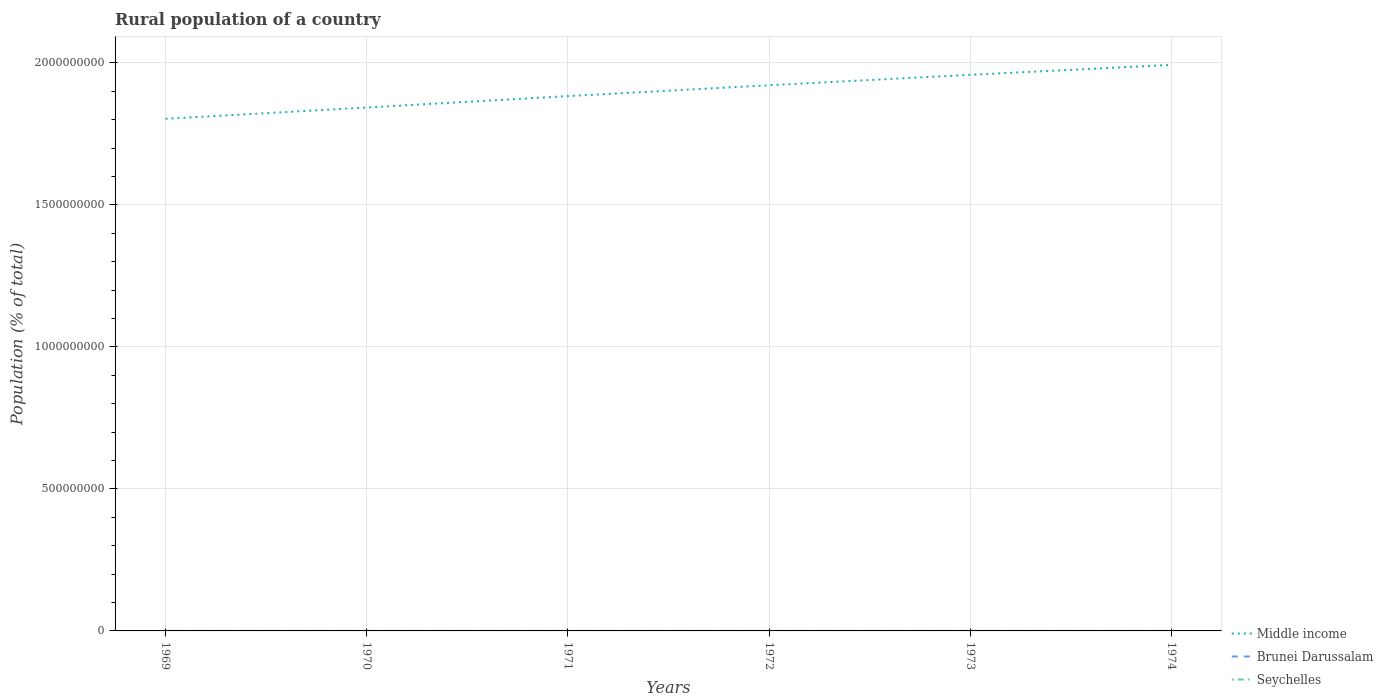How many different coloured lines are there?
Offer a terse response. 3. Does the line corresponding to Middle income intersect with the line corresponding to Brunei Darussalam?
Keep it short and to the point. No. Across all years, what is the maximum rural population in Brunei Darussalam?
Make the answer very short. 4.97e+04. In which year was the rural population in Middle income maximum?
Keep it short and to the point. 1969. What is the total rural population in Middle income in the graph?
Ensure brevity in your answer.  -7.99e+07. What is the difference between the highest and the second highest rural population in Middle income?
Your answer should be very brief. 1.90e+08. Is the rural population in Middle income strictly greater than the rural population in Brunei Darussalam over the years?
Offer a terse response. No. What is the difference between two consecutive major ticks on the Y-axis?
Offer a terse response. 5.00e+08. Are the values on the major ticks of Y-axis written in scientific E-notation?
Make the answer very short. No. Does the graph contain any zero values?
Your response must be concise. No. Where does the legend appear in the graph?
Your response must be concise. Bottom right. How many legend labels are there?
Ensure brevity in your answer.  3. How are the legend labels stacked?
Keep it short and to the point. Vertical. What is the title of the graph?
Ensure brevity in your answer.  Rural population of a country. Does "Cyprus" appear as one of the legend labels in the graph?
Your answer should be very brief. No. What is the label or title of the Y-axis?
Make the answer very short. Population (% of total). What is the Population (% of total) in Middle income in 1969?
Give a very brief answer. 1.80e+09. What is the Population (% of total) in Brunei Darussalam in 1969?
Your answer should be very brief. 4.97e+04. What is the Population (% of total) of Seychelles in 1969?
Give a very brief answer. 3.25e+04. What is the Population (% of total) in Middle income in 1970?
Your answer should be very brief. 1.84e+09. What is the Population (% of total) in Brunei Darussalam in 1970?
Give a very brief answer. 4.97e+04. What is the Population (% of total) of Seychelles in 1970?
Your answer should be compact. 3.27e+04. What is the Population (% of total) in Middle income in 1971?
Ensure brevity in your answer.  1.88e+09. What is the Population (% of total) of Brunei Darussalam in 1971?
Ensure brevity in your answer.  4.97e+04. What is the Population (% of total) in Seychelles in 1971?
Your answer should be compact. 3.27e+04. What is the Population (% of total) in Middle income in 1972?
Provide a short and direct response. 1.92e+09. What is the Population (% of total) in Brunei Darussalam in 1972?
Provide a short and direct response. 5.21e+04. What is the Population (% of total) of Seychelles in 1972?
Your answer should be very brief. 3.26e+04. What is the Population (% of total) of Middle income in 1973?
Provide a succinct answer. 1.96e+09. What is the Population (% of total) in Brunei Darussalam in 1973?
Your response must be concise. 5.50e+04. What is the Population (% of total) of Seychelles in 1973?
Make the answer very short. 3.25e+04. What is the Population (% of total) of Middle income in 1974?
Keep it short and to the point. 1.99e+09. What is the Population (% of total) of Brunei Darussalam in 1974?
Your answer should be compact. 5.80e+04. What is the Population (% of total) of Seychelles in 1974?
Provide a succinct answer. 3.23e+04. Across all years, what is the maximum Population (% of total) in Middle income?
Make the answer very short. 1.99e+09. Across all years, what is the maximum Population (% of total) of Brunei Darussalam?
Keep it short and to the point. 5.80e+04. Across all years, what is the maximum Population (% of total) of Seychelles?
Provide a short and direct response. 3.27e+04. Across all years, what is the minimum Population (% of total) of Middle income?
Your response must be concise. 1.80e+09. Across all years, what is the minimum Population (% of total) in Brunei Darussalam?
Ensure brevity in your answer.  4.97e+04. Across all years, what is the minimum Population (% of total) in Seychelles?
Your response must be concise. 3.23e+04. What is the total Population (% of total) of Middle income in the graph?
Your response must be concise. 1.14e+1. What is the total Population (% of total) of Brunei Darussalam in the graph?
Offer a very short reply. 3.14e+05. What is the total Population (% of total) of Seychelles in the graph?
Your answer should be compact. 1.95e+05. What is the difference between the Population (% of total) of Middle income in 1969 and that in 1970?
Your answer should be very brief. -3.98e+07. What is the difference between the Population (% of total) of Brunei Darussalam in 1969 and that in 1970?
Make the answer very short. -55. What is the difference between the Population (% of total) in Seychelles in 1969 and that in 1970?
Ensure brevity in your answer.  -113. What is the difference between the Population (% of total) in Middle income in 1969 and that in 1971?
Ensure brevity in your answer.  -7.99e+07. What is the difference between the Population (% of total) in Seychelles in 1969 and that in 1971?
Provide a succinct answer. -169. What is the difference between the Population (% of total) in Middle income in 1969 and that in 1972?
Keep it short and to the point. -1.18e+08. What is the difference between the Population (% of total) in Brunei Darussalam in 1969 and that in 1972?
Give a very brief answer. -2483. What is the difference between the Population (% of total) in Seychelles in 1969 and that in 1972?
Offer a very short reply. -83. What is the difference between the Population (% of total) of Middle income in 1969 and that in 1973?
Offer a very short reply. -1.55e+08. What is the difference between the Population (% of total) in Brunei Darussalam in 1969 and that in 1973?
Ensure brevity in your answer.  -5383. What is the difference between the Population (% of total) of Middle income in 1969 and that in 1974?
Offer a very short reply. -1.90e+08. What is the difference between the Population (% of total) of Brunei Darussalam in 1969 and that in 1974?
Make the answer very short. -8375. What is the difference between the Population (% of total) of Seychelles in 1969 and that in 1974?
Your answer should be very brief. 254. What is the difference between the Population (% of total) in Middle income in 1970 and that in 1971?
Offer a terse response. -4.01e+07. What is the difference between the Population (% of total) of Brunei Darussalam in 1970 and that in 1971?
Keep it short and to the point. 63. What is the difference between the Population (% of total) in Seychelles in 1970 and that in 1971?
Provide a succinct answer. -56. What is the difference between the Population (% of total) of Middle income in 1970 and that in 1972?
Offer a very short reply. -7.84e+07. What is the difference between the Population (% of total) of Brunei Darussalam in 1970 and that in 1972?
Provide a succinct answer. -2428. What is the difference between the Population (% of total) of Middle income in 1970 and that in 1973?
Make the answer very short. -1.15e+08. What is the difference between the Population (% of total) of Brunei Darussalam in 1970 and that in 1973?
Offer a very short reply. -5328. What is the difference between the Population (% of total) in Seychelles in 1970 and that in 1973?
Give a very brief answer. 167. What is the difference between the Population (% of total) of Middle income in 1970 and that in 1974?
Keep it short and to the point. -1.50e+08. What is the difference between the Population (% of total) in Brunei Darussalam in 1970 and that in 1974?
Ensure brevity in your answer.  -8320. What is the difference between the Population (% of total) of Seychelles in 1970 and that in 1974?
Provide a succinct answer. 367. What is the difference between the Population (% of total) in Middle income in 1971 and that in 1972?
Keep it short and to the point. -3.83e+07. What is the difference between the Population (% of total) in Brunei Darussalam in 1971 and that in 1972?
Provide a succinct answer. -2491. What is the difference between the Population (% of total) in Seychelles in 1971 and that in 1972?
Offer a very short reply. 86. What is the difference between the Population (% of total) of Middle income in 1971 and that in 1973?
Ensure brevity in your answer.  -7.51e+07. What is the difference between the Population (% of total) of Brunei Darussalam in 1971 and that in 1973?
Your response must be concise. -5391. What is the difference between the Population (% of total) in Seychelles in 1971 and that in 1973?
Offer a terse response. 223. What is the difference between the Population (% of total) of Middle income in 1971 and that in 1974?
Provide a short and direct response. -1.10e+08. What is the difference between the Population (% of total) of Brunei Darussalam in 1971 and that in 1974?
Your response must be concise. -8383. What is the difference between the Population (% of total) of Seychelles in 1971 and that in 1974?
Provide a succinct answer. 423. What is the difference between the Population (% of total) of Middle income in 1972 and that in 1973?
Provide a short and direct response. -3.68e+07. What is the difference between the Population (% of total) in Brunei Darussalam in 1972 and that in 1973?
Offer a terse response. -2900. What is the difference between the Population (% of total) in Seychelles in 1972 and that in 1973?
Ensure brevity in your answer.  137. What is the difference between the Population (% of total) of Middle income in 1972 and that in 1974?
Keep it short and to the point. -7.17e+07. What is the difference between the Population (% of total) of Brunei Darussalam in 1972 and that in 1974?
Offer a terse response. -5892. What is the difference between the Population (% of total) of Seychelles in 1972 and that in 1974?
Give a very brief answer. 337. What is the difference between the Population (% of total) of Middle income in 1973 and that in 1974?
Your answer should be compact. -3.49e+07. What is the difference between the Population (% of total) in Brunei Darussalam in 1973 and that in 1974?
Your answer should be very brief. -2992. What is the difference between the Population (% of total) of Seychelles in 1973 and that in 1974?
Provide a succinct answer. 200. What is the difference between the Population (% of total) of Middle income in 1969 and the Population (% of total) of Brunei Darussalam in 1970?
Your answer should be compact. 1.80e+09. What is the difference between the Population (% of total) in Middle income in 1969 and the Population (% of total) in Seychelles in 1970?
Offer a terse response. 1.80e+09. What is the difference between the Population (% of total) in Brunei Darussalam in 1969 and the Population (% of total) in Seychelles in 1970?
Offer a terse response. 1.70e+04. What is the difference between the Population (% of total) of Middle income in 1969 and the Population (% of total) of Brunei Darussalam in 1971?
Offer a very short reply. 1.80e+09. What is the difference between the Population (% of total) in Middle income in 1969 and the Population (% of total) in Seychelles in 1971?
Give a very brief answer. 1.80e+09. What is the difference between the Population (% of total) of Brunei Darussalam in 1969 and the Population (% of total) of Seychelles in 1971?
Offer a terse response. 1.69e+04. What is the difference between the Population (% of total) of Middle income in 1969 and the Population (% of total) of Brunei Darussalam in 1972?
Provide a short and direct response. 1.80e+09. What is the difference between the Population (% of total) in Middle income in 1969 and the Population (% of total) in Seychelles in 1972?
Your answer should be compact. 1.80e+09. What is the difference between the Population (% of total) of Brunei Darussalam in 1969 and the Population (% of total) of Seychelles in 1972?
Offer a very short reply. 1.70e+04. What is the difference between the Population (% of total) in Middle income in 1969 and the Population (% of total) in Brunei Darussalam in 1973?
Ensure brevity in your answer.  1.80e+09. What is the difference between the Population (% of total) of Middle income in 1969 and the Population (% of total) of Seychelles in 1973?
Ensure brevity in your answer.  1.80e+09. What is the difference between the Population (% of total) of Brunei Darussalam in 1969 and the Population (% of total) of Seychelles in 1973?
Ensure brevity in your answer.  1.72e+04. What is the difference between the Population (% of total) in Middle income in 1969 and the Population (% of total) in Brunei Darussalam in 1974?
Offer a terse response. 1.80e+09. What is the difference between the Population (% of total) of Middle income in 1969 and the Population (% of total) of Seychelles in 1974?
Offer a very short reply. 1.80e+09. What is the difference between the Population (% of total) in Brunei Darussalam in 1969 and the Population (% of total) in Seychelles in 1974?
Ensure brevity in your answer.  1.74e+04. What is the difference between the Population (% of total) of Middle income in 1970 and the Population (% of total) of Brunei Darussalam in 1971?
Provide a succinct answer. 1.84e+09. What is the difference between the Population (% of total) of Middle income in 1970 and the Population (% of total) of Seychelles in 1971?
Ensure brevity in your answer.  1.84e+09. What is the difference between the Population (% of total) in Brunei Darussalam in 1970 and the Population (% of total) in Seychelles in 1971?
Provide a short and direct response. 1.70e+04. What is the difference between the Population (% of total) in Middle income in 1970 and the Population (% of total) in Brunei Darussalam in 1972?
Make the answer very short. 1.84e+09. What is the difference between the Population (% of total) in Middle income in 1970 and the Population (% of total) in Seychelles in 1972?
Make the answer very short. 1.84e+09. What is the difference between the Population (% of total) of Brunei Darussalam in 1970 and the Population (% of total) of Seychelles in 1972?
Your answer should be very brief. 1.71e+04. What is the difference between the Population (% of total) of Middle income in 1970 and the Population (% of total) of Brunei Darussalam in 1973?
Keep it short and to the point. 1.84e+09. What is the difference between the Population (% of total) of Middle income in 1970 and the Population (% of total) of Seychelles in 1973?
Keep it short and to the point. 1.84e+09. What is the difference between the Population (% of total) in Brunei Darussalam in 1970 and the Population (% of total) in Seychelles in 1973?
Make the answer very short. 1.72e+04. What is the difference between the Population (% of total) in Middle income in 1970 and the Population (% of total) in Brunei Darussalam in 1974?
Give a very brief answer. 1.84e+09. What is the difference between the Population (% of total) in Middle income in 1970 and the Population (% of total) in Seychelles in 1974?
Your answer should be compact. 1.84e+09. What is the difference between the Population (% of total) of Brunei Darussalam in 1970 and the Population (% of total) of Seychelles in 1974?
Your answer should be very brief. 1.74e+04. What is the difference between the Population (% of total) of Middle income in 1971 and the Population (% of total) of Brunei Darussalam in 1972?
Offer a very short reply. 1.88e+09. What is the difference between the Population (% of total) in Middle income in 1971 and the Population (% of total) in Seychelles in 1972?
Your answer should be compact. 1.88e+09. What is the difference between the Population (% of total) of Brunei Darussalam in 1971 and the Population (% of total) of Seychelles in 1972?
Your answer should be very brief. 1.70e+04. What is the difference between the Population (% of total) in Middle income in 1971 and the Population (% of total) in Brunei Darussalam in 1973?
Give a very brief answer. 1.88e+09. What is the difference between the Population (% of total) of Middle income in 1971 and the Population (% of total) of Seychelles in 1973?
Ensure brevity in your answer.  1.88e+09. What is the difference between the Population (% of total) of Brunei Darussalam in 1971 and the Population (% of total) of Seychelles in 1973?
Ensure brevity in your answer.  1.72e+04. What is the difference between the Population (% of total) in Middle income in 1971 and the Population (% of total) in Brunei Darussalam in 1974?
Make the answer very short. 1.88e+09. What is the difference between the Population (% of total) in Middle income in 1971 and the Population (% of total) in Seychelles in 1974?
Provide a short and direct response. 1.88e+09. What is the difference between the Population (% of total) in Brunei Darussalam in 1971 and the Population (% of total) in Seychelles in 1974?
Make the answer very short. 1.74e+04. What is the difference between the Population (% of total) in Middle income in 1972 and the Population (% of total) in Brunei Darussalam in 1973?
Provide a short and direct response. 1.92e+09. What is the difference between the Population (% of total) of Middle income in 1972 and the Population (% of total) of Seychelles in 1973?
Keep it short and to the point. 1.92e+09. What is the difference between the Population (% of total) of Brunei Darussalam in 1972 and the Population (% of total) of Seychelles in 1973?
Your answer should be compact. 1.97e+04. What is the difference between the Population (% of total) of Middle income in 1972 and the Population (% of total) of Brunei Darussalam in 1974?
Your response must be concise. 1.92e+09. What is the difference between the Population (% of total) in Middle income in 1972 and the Population (% of total) in Seychelles in 1974?
Ensure brevity in your answer.  1.92e+09. What is the difference between the Population (% of total) in Brunei Darussalam in 1972 and the Population (% of total) in Seychelles in 1974?
Provide a short and direct response. 1.99e+04. What is the difference between the Population (% of total) in Middle income in 1973 and the Population (% of total) in Brunei Darussalam in 1974?
Your answer should be very brief. 1.96e+09. What is the difference between the Population (% of total) in Middle income in 1973 and the Population (% of total) in Seychelles in 1974?
Ensure brevity in your answer.  1.96e+09. What is the difference between the Population (% of total) of Brunei Darussalam in 1973 and the Population (% of total) of Seychelles in 1974?
Give a very brief answer. 2.28e+04. What is the average Population (% of total) in Middle income per year?
Your answer should be very brief. 1.90e+09. What is the average Population (% of total) in Brunei Darussalam per year?
Ensure brevity in your answer.  5.24e+04. What is the average Population (% of total) in Seychelles per year?
Make the answer very short. 3.26e+04. In the year 1969, what is the difference between the Population (% of total) of Middle income and Population (% of total) of Brunei Darussalam?
Your answer should be compact. 1.80e+09. In the year 1969, what is the difference between the Population (% of total) of Middle income and Population (% of total) of Seychelles?
Keep it short and to the point. 1.80e+09. In the year 1969, what is the difference between the Population (% of total) of Brunei Darussalam and Population (% of total) of Seychelles?
Your response must be concise. 1.71e+04. In the year 1970, what is the difference between the Population (% of total) in Middle income and Population (% of total) in Brunei Darussalam?
Your response must be concise. 1.84e+09. In the year 1970, what is the difference between the Population (% of total) of Middle income and Population (% of total) of Seychelles?
Give a very brief answer. 1.84e+09. In the year 1970, what is the difference between the Population (% of total) of Brunei Darussalam and Population (% of total) of Seychelles?
Ensure brevity in your answer.  1.71e+04. In the year 1971, what is the difference between the Population (% of total) in Middle income and Population (% of total) in Brunei Darussalam?
Offer a terse response. 1.88e+09. In the year 1971, what is the difference between the Population (% of total) of Middle income and Population (% of total) of Seychelles?
Ensure brevity in your answer.  1.88e+09. In the year 1971, what is the difference between the Population (% of total) in Brunei Darussalam and Population (% of total) in Seychelles?
Give a very brief answer. 1.69e+04. In the year 1972, what is the difference between the Population (% of total) in Middle income and Population (% of total) in Brunei Darussalam?
Keep it short and to the point. 1.92e+09. In the year 1972, what is the difference between the Population (% of total) in Middle income and Population (% of total) in Seychelles?
Offer a very short reply. 1.92e+09. In the year 1972, what is the difference between the Population (% of total) of Brunei Darussalam and Population (% of total) of Seychelles?
Provide a short and direct response. 1.95e+04. In the year 1973, what is the difference between the Population (% of total) in Middle income and Population (% of total) in Brunei Darussalam?
Your response must be concise. 1.96e+09. In the year 1973, what is the difference between the Population (% of total) of Middle income and Population (% of total) of Seychelles?
Keep it short and to the point. 1.96e+09. In the year 1973, what is the difference between the Population (% of total) in Brunei Darussalam and Population (% of total) in Seychelles?
Ensure brevity in your answer.  2.26e+04. In the year 1974, what is the difference between the Population (% of total) of Middle income and Population (% of total) of Brunei Darussalam?
Give a very brief answer. 1.99e+09. In the year 1974, what is the difference between the Population (% of total) in Middle income and Population (% of total) in Seychelles?
Your response must be concise. 1.99e+09. In the year 1974, what is the difference between the Population (% of total) in Brunei Darussalam and Population (% of total) in Seychelles?
Make the answer very short. 2.57e+04. What is the ratio of the Population (% of total) in Middle income in 1969 to that in 1970?
Offer a very short reply. 0.98. What is the ratio of the Population (% of total) of Brunei Darussalam in 1969 to that in 1970?
Ensure brevity in your answer.  1. What is the ratio of the Population (% of total) in Middle income in 1969 to that in 1971?
Give a very brief answer. 0.96. What is the ratio of the Population (% of total) of Seychelles in 1969 to that in 1971?
Give a very brief answer. 0.99. What is the ratio of the Population (% of total) of Middle income in 1969 to that in 1972?
Offer a very short reply. 0.94. What is the ratio of the Population (% of total) of Brunei Darussalam in 1969 to that in 1972?
Your answer should be compact. 0.95. What is the ratio of the Population (% of total) of Seychelles in 1969 to that in 1972?
Ensure brevity in your answer.  1. What is the ratio of the Population (% of total) of Middle income in 1969 to that in 1973?
Your response must be concise. 0.92. What is the ratio of the Population (% of total) in Brunei Darussalam in 1969 to that in 1973?
Your response must be concise. 0.9. What is the ratio of the Population (% of total) of Seychelles in 1969 to that in 1973?
Keep it short and to the point. 1. What is the ratio of the Population (% of total) of Middle income in 1969 to that in 1974?
Provide a short and direct response. 0.9. What is the ratio of the Population (% of total) of Brunei Darussalam in 1969 to that in 1974?
Keep it short and to the point. 0.86. What is the ratio of the Population (% of total) in Seychelles in 1969 to that in 1974?
Your answer should be very brief. 1.01. What is the ratio of the Population (% of total) in Middle income in 1970 to that in 1971?
Offer a very short reply. 0.98. What is the ratio of the Population (% of total) of Brunei Darussalam in 1970 to that in 1971?
Keep it short and to the point. 1. What is the ratio of the Population (% of total) of Seychelles in 1970 to that in 1971?
Give a very brief answer. 1. What is the ratio of the Population (% of total) in Middle income in 1970 to that in 1972?
Your answer should be very brief. 0.96. What is the ratio of the Population (% of total) of Brunei Darussalam in 1970 to that in 1972?
Keep it short and to the point. 0.95. What is the ratio of the Population (% of total) in Brunei Darussalam in 1970 to that in 1973?
Give a very brief answer. 0.9. What is the ratio of the Population (% of total) in Seychelles in 1970 to that in 1973?
Provide a short and direct response. 1.01. What is the ratio of the Population (% of total) of Middle income in 1970 to that in 1974?
Keep it short and to the point. 0.92. What is the ratio of the Population (% of total) in Brunei Darussalam in 1970 to that in 1974?
Make the answer very short. 0.86. What is the ratio of the Population (% of total) in Seychelles in 1970 to that in 1974?
Give a very brief answer. 1.01. What is the ratio of the Population (% of total) of Middle income in 1971 to that in 1972?
Your response must be concise. 0.98. What is the ratio of the Population (% of total) of Brunei Darussalam in 1971 to that in 1972?
Provide a succinct answer. 0.95. What is the ratio of the Population (% of total) in Middle income in 1971 to that in 1973?
Provide a succinct answer. 0.96. What is the ratio of the Population (% of total) of Brunei Darussalam in 1971 to that in 1973?
Provide a short and direct response. 0.9. What is the ratio of the Population (% of total) in Middle income in 1971 to that in 1974?
Keep it short and to the point. 0.94. What is the ratio of the Population (% of total) in Brunei Darussalam in 1971 to that in 1974?
Provide a short and direct response. 0.86. What is the ratio of the Population (% of total) of Seychelles in 1971 to that in 1974?
Your answer should be very brief. 1.01. What is the ratio of the Population (% of total) of Middle income in 1972 to that in 1973?
Offer a very short reply. 0.98. What is the ratio of the Population (% of total) in Brunei Darussalam in 1972 to that in 1973?
Your answer should be compact. 0.95. What is the ratio of the Population (% of total) of Brunei Darussalam in 1972 to that in 1974?
Your answer should be compact. 0.9. What is the ratio of the Population (% of total) of Seychelles in 1972 to that in 1974?
Your response must be concise. 1.01. What is the ratio of the Population (% of total) of Middle income in 1973 to that in 1974?
Your response must be concise. 0.98. What is the ratio of the Population (% of total) in Brunei Darussalam in 1973 to that in 1974?
Give a very brief answer. 0.95. What is the ratio of the Population (% of total) in Seychelles in 1973 to that in 1974?
Make the answer very short. 1.01. What is the difference between the highest and the second highest Population (% of total) of Middle income?
Ensure brevity in your answer.  3.49e+07. What is the difference between the highest and the second highest Population (% of total) in Brunei Darussalam?
Provide a short and direct response. 2992. What is the difference between the highest and the lowest Population (% of total) in Middle income?
Keep it short and to the point. 1.90e+08. What is the difference between the highest and the lowest Population (% of total) of Brunei Darussalam?
Make the answer very short. 8383. What is the difference between the highest and the lowest Population (% of total) of Seychelles?
Your response must be concise. 423. 